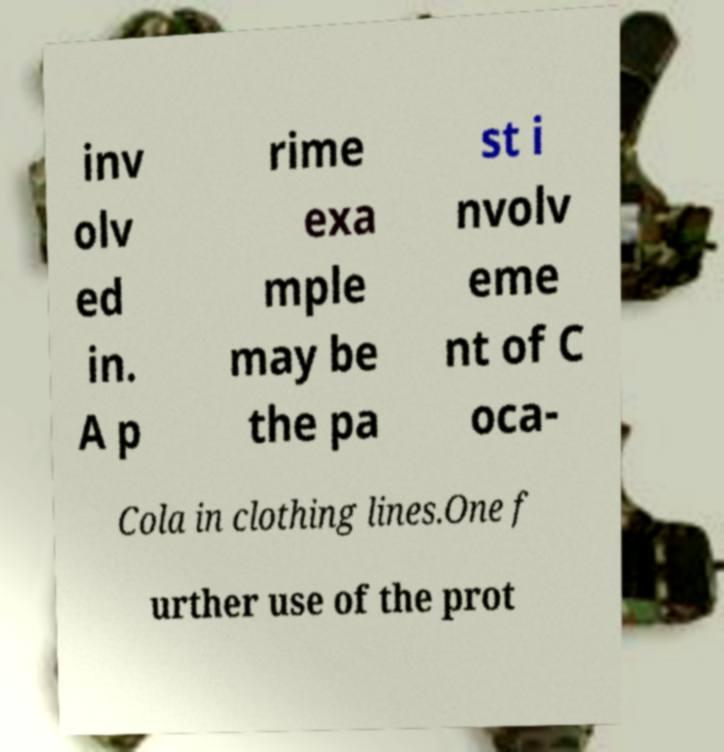Please identify and transcribe the text found in this image. inv olv ed in. A p rime exa mple may be the pa st i nvolv eme nt of C oca- Cola in clothing lines.One f urther use of the prot 